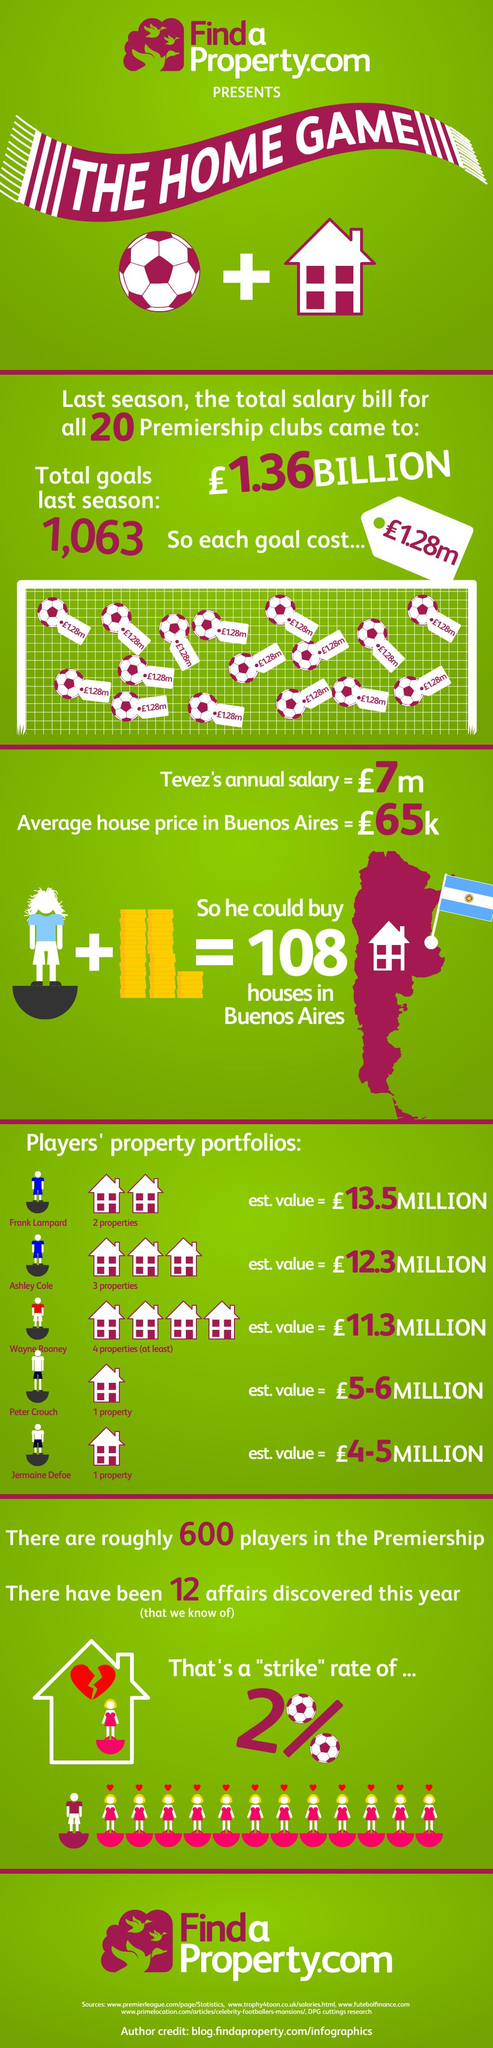Mention a couple of crucial points in this snapshot. In the previous season, a grand total of 1,063 goals were scored. According to the estimates, the cost of each goal is approximately 1.28 million pounds. The average cost of buying a home in the capital of Argentina is approximately 65,000 pounds. Wayne Rooney is the player who has the most number of properties listed in the graphic. Frank Lampard's property is estimated to have the highest value among all players. 